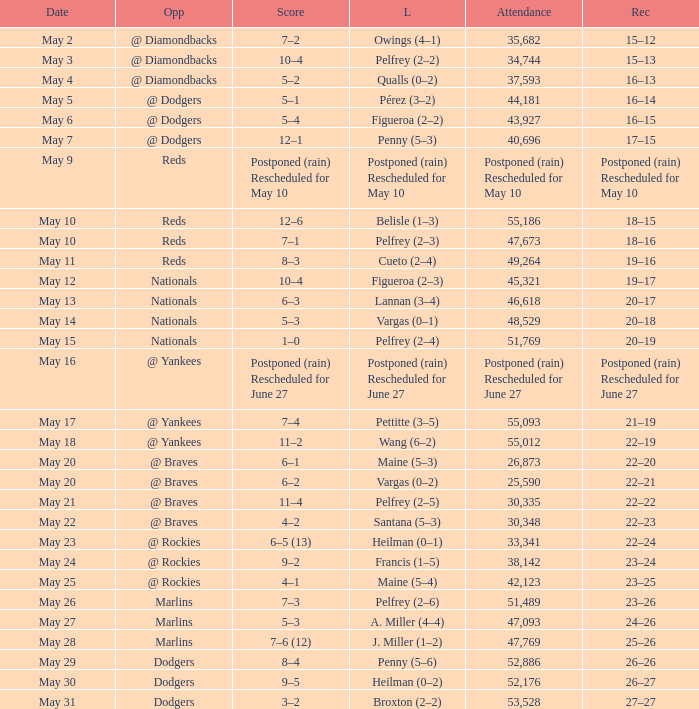Attendance of 30,335 had what record? 22–22. 